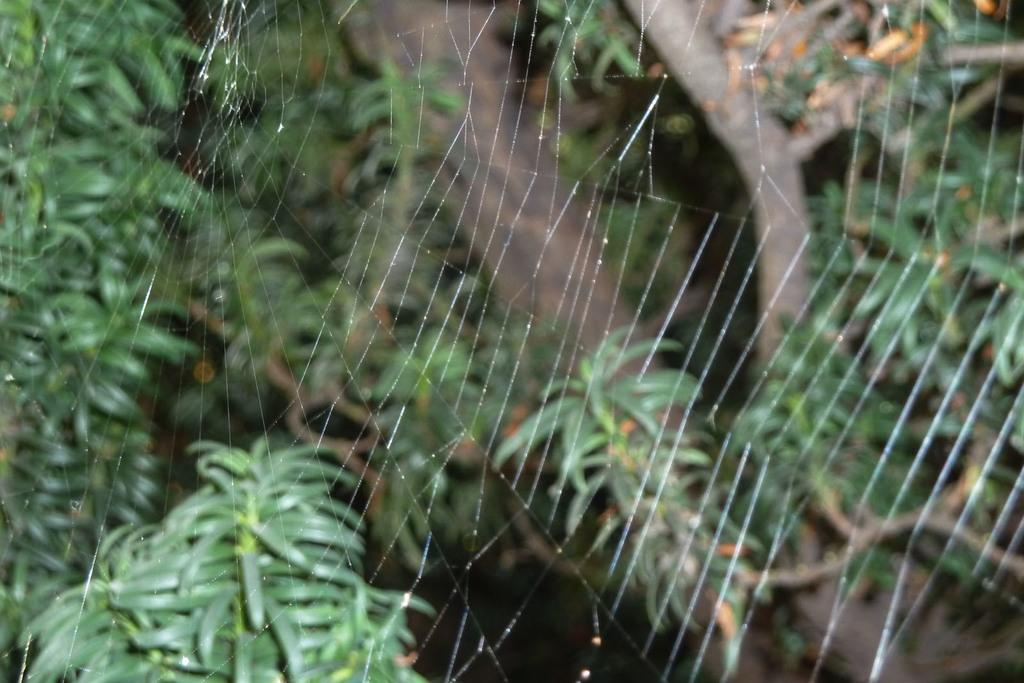What is the main subject of the image? There is a spider web in the image. What can be seen in the background of the image? There is a branch and leaves of a tree visible in the background of the image. How is the background of the image depicted? The background of the image is slightly blurry. What type of quartz can be seen in the image? There is no quartz present in the image. How many drawers are visible in the image? There are no drawers present in the image. 